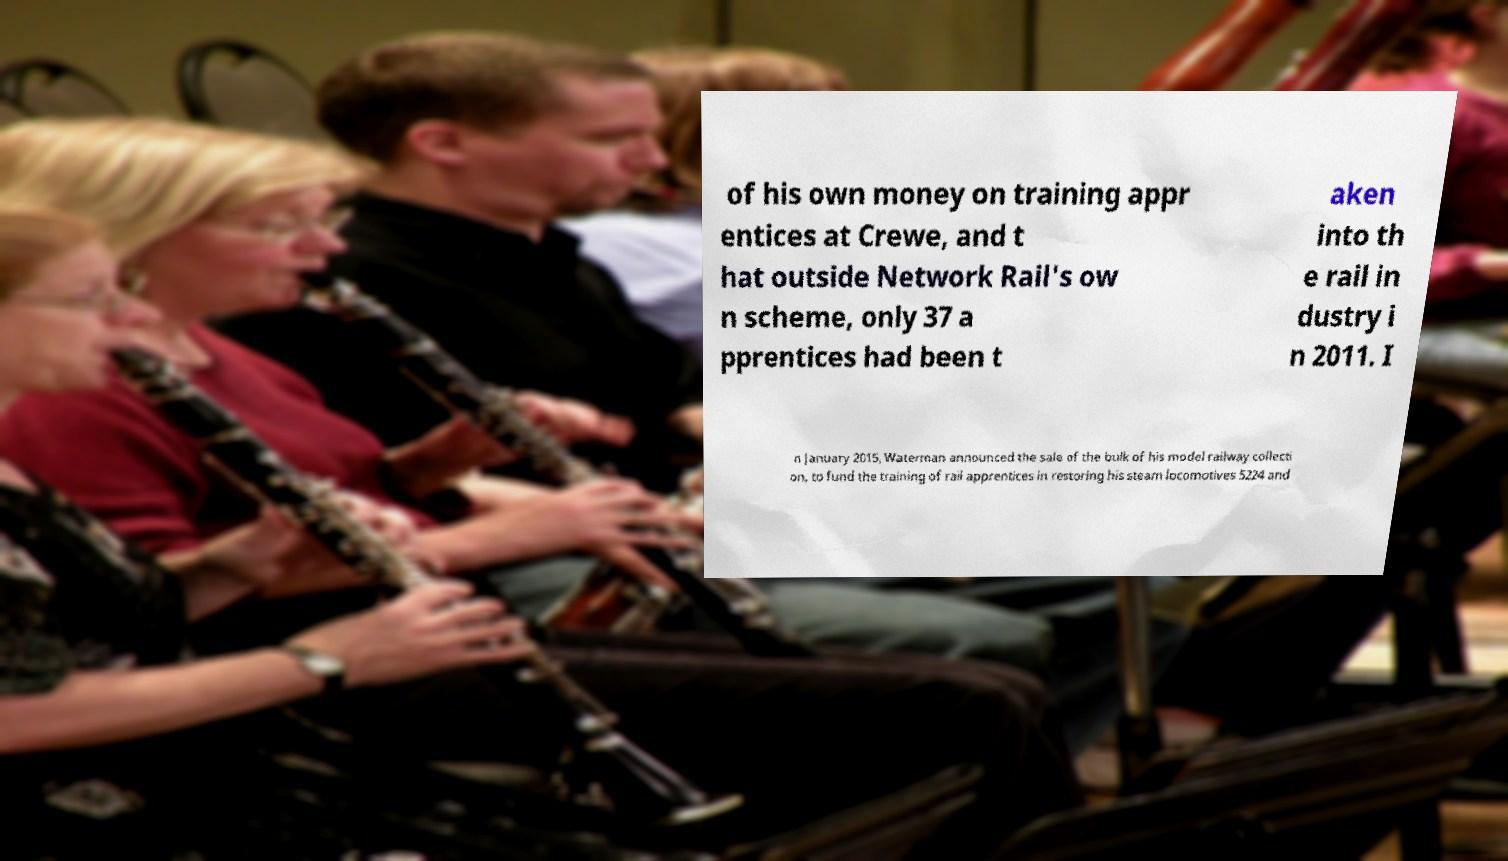Could you extract and type out the text from this image? of his own money on training appr entices at Crewe, and t hat outside Network Rail's ow n scheme, only 37 a pprentices had been t aken into th e rail in dustry i n 2011. I n January 2015, Waterman announced the sale of the bulk of his model railway collecti on, to fund the training of rail apprentices in restoring his steam locomotives 5224 and 